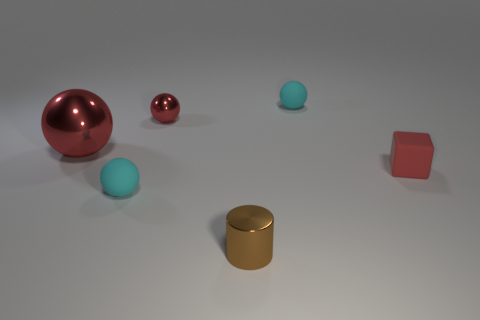Do the large red shiny object and the tiny brown object have the same shape?
Offer a very short reply. No. How many other things are the same shape as the large thing?
Your answer should be very brief. 3. There is a metallic sphere that is behind the large sphere; what color is it?
Offer a terse response. Red. Is the size of the brown shiny object the same as the red matte thing?
Offer a very short reply. Yes. There is a tiny cyan object that is in front of the tiny shiny object that is behind the tiny red rubber thing; what is its material?
Make the answer very short. Rubber. How many matte cubes are the same color as the large ball?
Your answer should be compact. 1. Are there any other things that are the same material as the big sphere?
Your response must be concise. Yes. Is the number of tiny metal spheres to the right of the tiny brown object less than the number of big gray shiny spheres?
Offer a terse response. No. The small matte thing to the right of the tiny cyan sphere that is to the right of the metal cylinder is what color?
Offer a very short reply. Red. How big is the cyan matte object left of the tiny rubber sphere that is behind the tiny red thing on the left side of the red matte cube?
Provide a short and direct response. Small. 